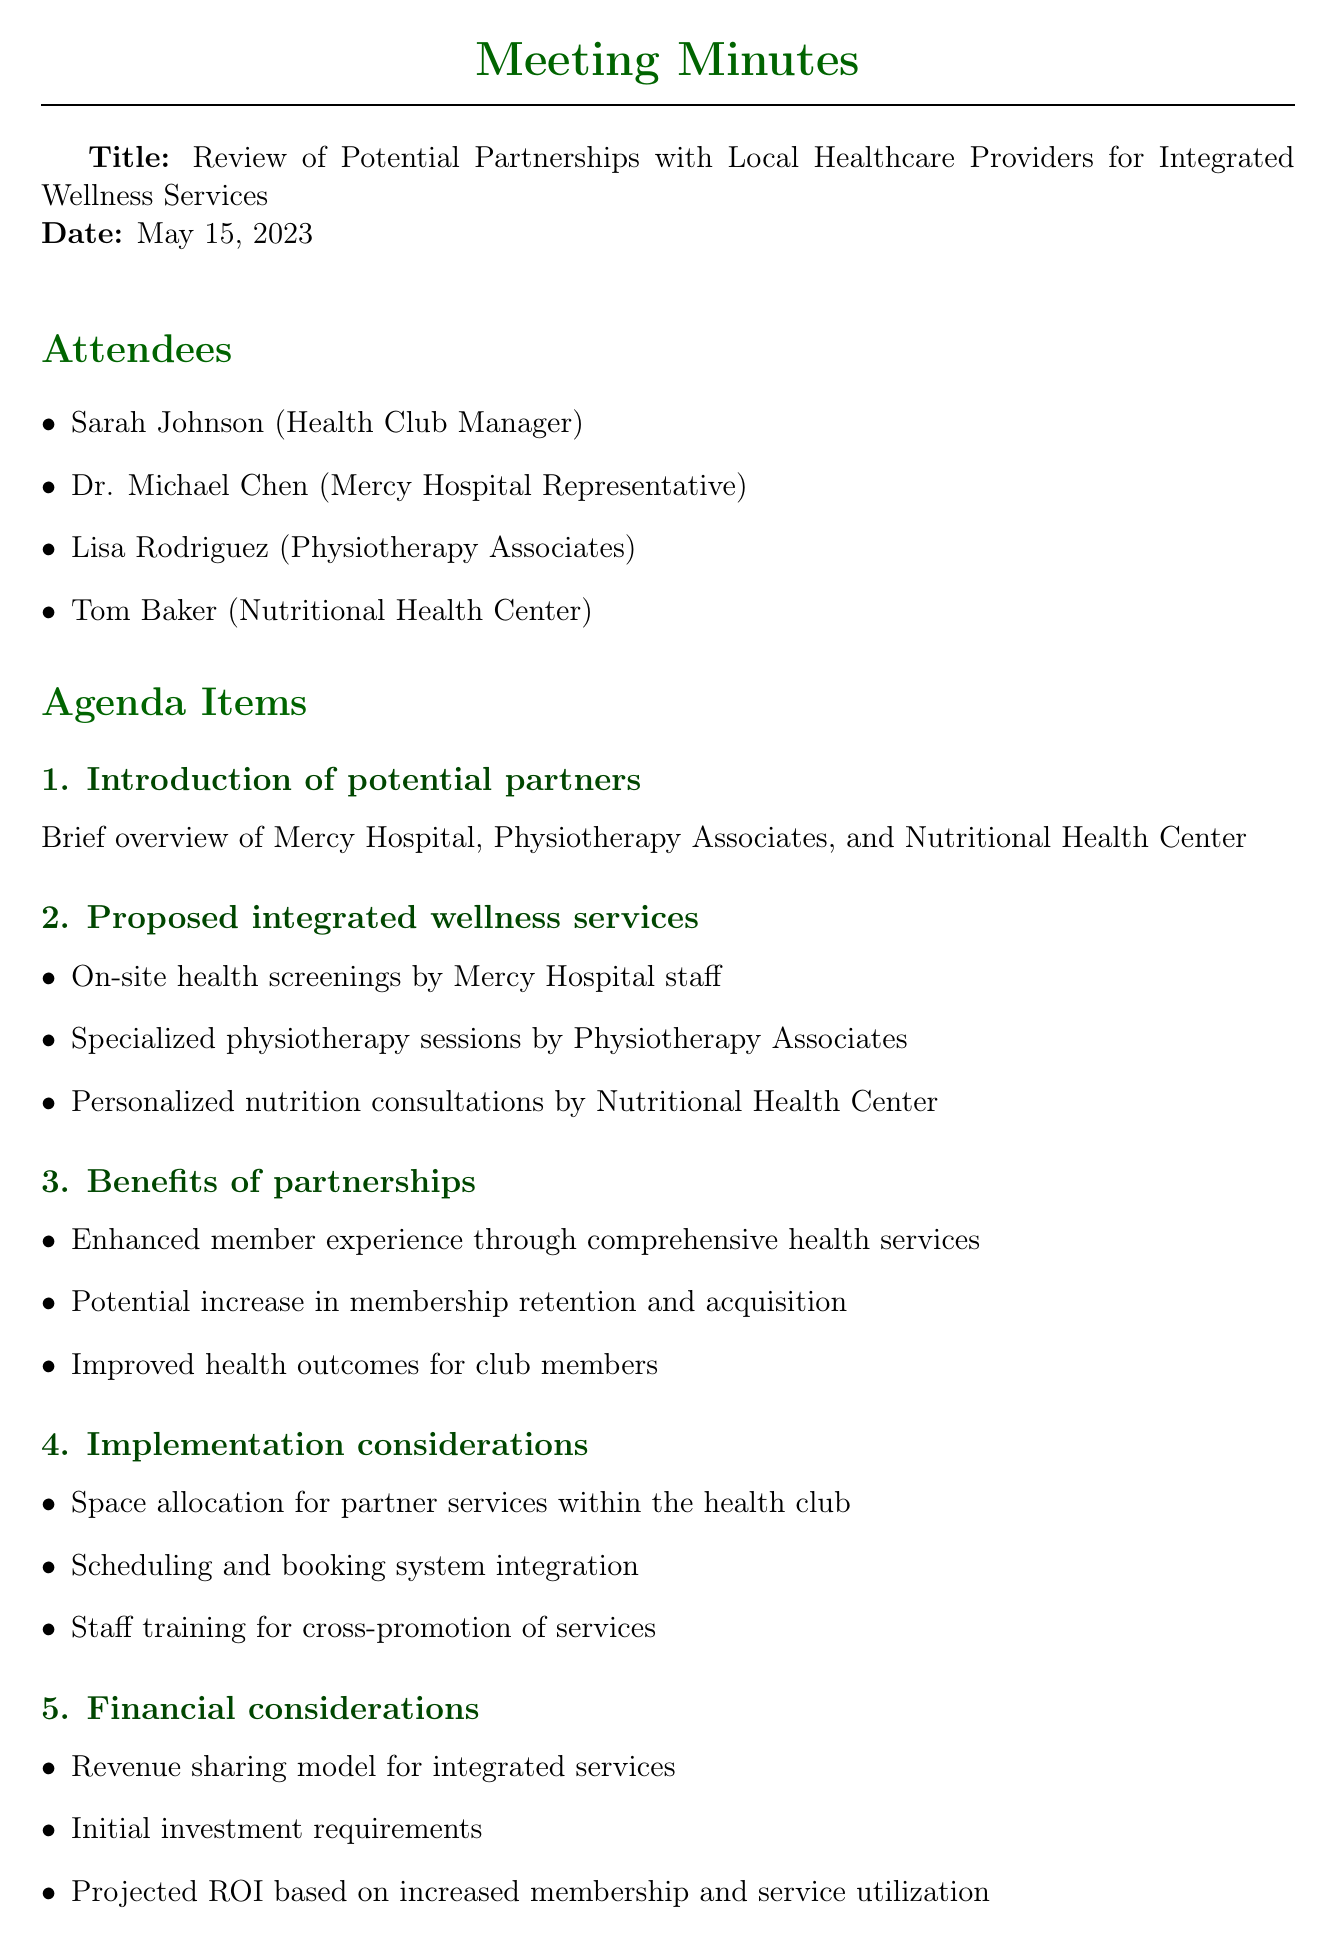What is the date of the meeting? The date of the meeting is clearly stated in the document.
Answer: May 15, 2023 Who is the representative from Mercy Hospital? The document lists the attendees and their affiliations, specifically mentioning Mercy Hospital.
Answer: Dr. Michael Chen What are the proposed integrated wellness services? This item is detailed under the agenda items, listing specific services.
Answer: On-site health screenings, specialized physiotherapy, personalized nutrition consultations What are the potential benefits of partnerships? The benefits are outlined in a specific section of the document.
Answer: Enhanced member experience, increase in membership retention, improved health outcomes What action is Sarah responsible for? The action items section specifies the responsibilities assigned to attendees after the meeting.
Answer: Coordinate follow-up meetings What is one implementation consideration mentioned? This detail is provided in the implementation considerations section of the document.
Answer: Space allocation for partner services How many attendees were present at the meeting? The number of attendees can be counted from the list provided in the document.
Answer: Four What is the next step regarding the marketing strategy? The document outlines specific next steps to be taken following the meeting.
Answer: Develop marketing strategy for integrated services 